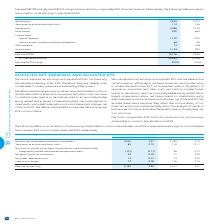According to Bce's financial document, How is adjusted EBITDA defined? Based on the financial document, the answer is operating revenues less operating costs as shown in BCE’s consolidated income statements. Also, How is adjusted EBITDA margin defined? Based on the financial document, the answer is adjusted EBITDA divided by operating revenues. Also, What is the Net earnings for 2019? According to the financial document, 3,253. The relevant text states: "Net earnings 3,253 2,973..." Also, can you calculate: What is the percentage of interest expense of finance costs in 2018? To answer this question, I need to perform calculations using the financial data. The calculation is: 1,000/(1,000+69), which equals 93.55 (percentage). This is based on the information: "Amortization 902 869 Interest expense 1,132 1,000..." The key data points involved are: 1,000, 69. Also, can you calculate: What is the change in the adjusted EBITDA margin in 2019? Based on the calculation: 42.2%-40.6%, the result is 1.6 (percentage). This is based on the information: "Adjusted EBITDA margin 42.2% 40.6% Adjusted EBITDA margin 42.2% 40.6%..." The key data points involved are: 40.6, 42.2. Also, can you calculate: What is the total net earnings in 2018 and 2019? Based on the calculation: 3,253+2,973, the result is 6226. This is based on the information: "Net earnings 3,253 2,973 Net earnings 3,253 2,973..." The key data points involved are: 2,973, 3,253. 